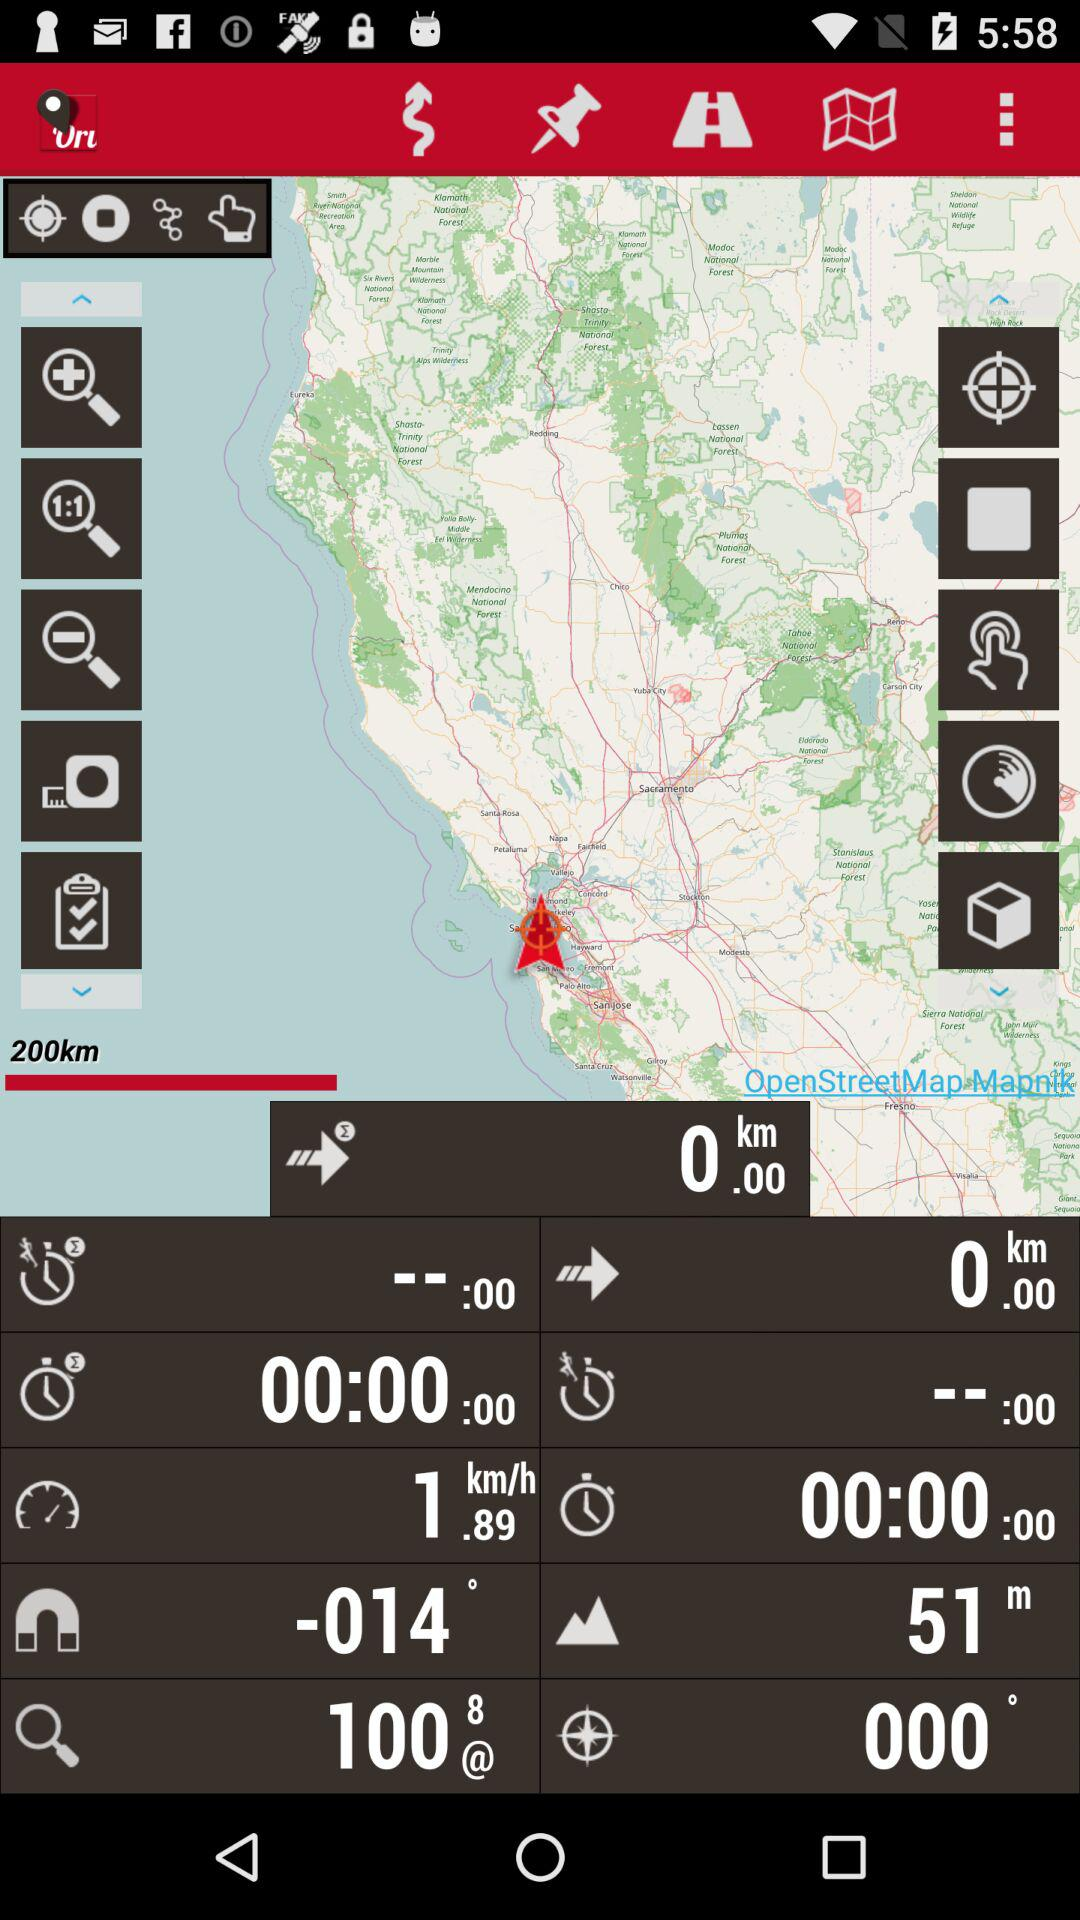What is the height? The height is 51m. 